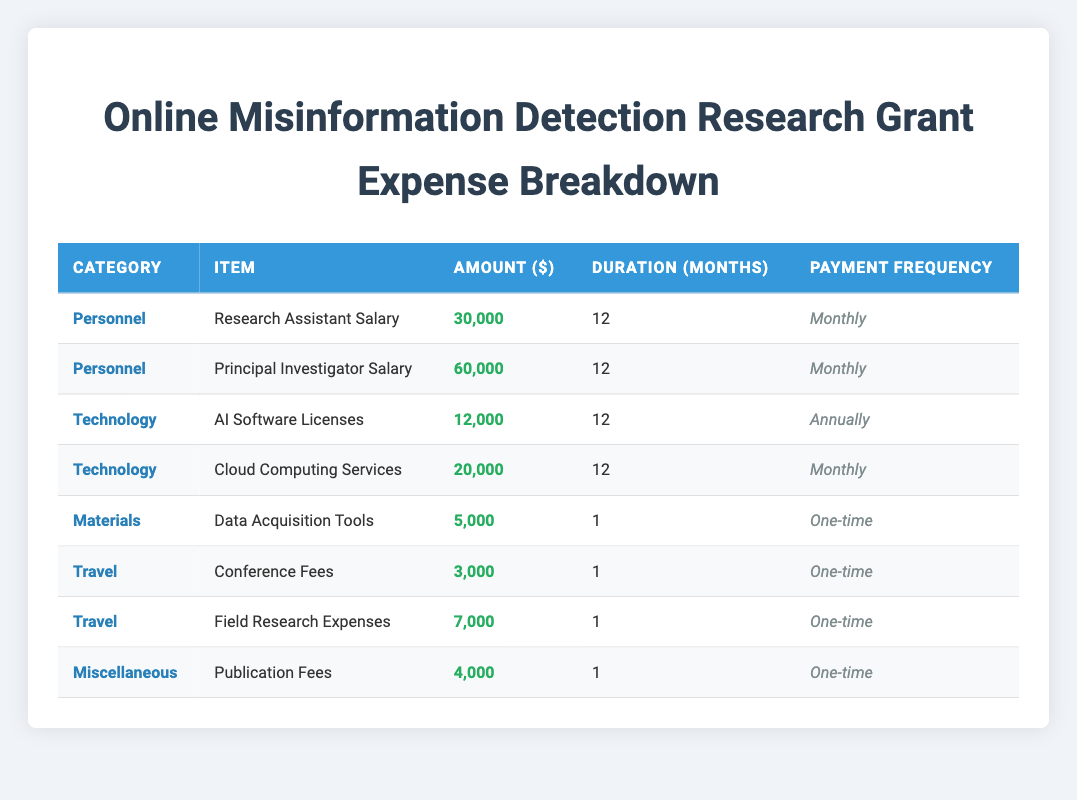What is the total amount allocated for personnel expenses? There are two personnel expenses listed in the table: the Research Assistant Salary is 30,000 and the Principal Investigator Salary is 60,000. To find the total, we sum these amounts: 30,000 + 60,000 = 90,000.
Answer: 90,000 How much is spent on technology each month? There are two technology items with monthly payments: AI Software Licenses is paid annually (12,000), and Cloud Computing Services is 20,000 monthly. Since AI Software Licenses is an annual payment, we only consider the monthly payment for Cloud Computing Services, which is 20,000.
Answer: 20,000 Is the total amount for travel expenses greater than the amount for materials? The travel expenses include Conference Fees (3,000) and Field Research Expenses (7,000), totaling 10,000. The materials expense, Data Acquisition Tools, is 5,000. Since 10,000 is greater than 5,000, the statement is true.
Answer: Yes What is the average monthly cost across all expenses? To find the average monthly cost, we need to consider only the monthly payments. The monthly costs include: Research Assistant Salary (30,000), Principal Investigator Salary (60,000), Cloud Computing Services (20,000); these total to 110,000 for 12 months. Additionally, AI Software Licenses contributes 1,000 monthly (12,000 annual / 12). So, the total monthly cost is 111,000. The average monthly cost is 111,000 / 12 = 9,250.
Answer: 9,250 Which category has the highest total expense, and what is that total? The highest category needs to be identified through a sum of its expenses. Personnel totals 90,000; Technology (Cloud Computing) is 20,000 (AI Licenses is annual); Travel totals 10,000; Materials is 5,000; Miscellaneous is 4,000. The highest is Personnel at 90,000.
Answer: Personnel, 90,000 